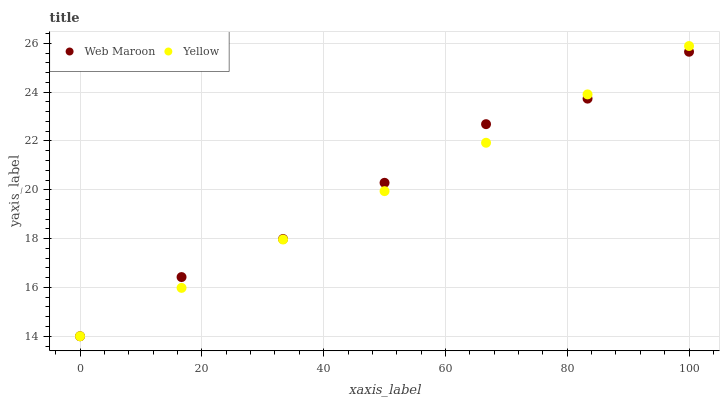Does Yellow have the minimum area under the curve?
Answer yes or no. Yes. Does Web Maroon have the maximum area under the curve?
Answer yes or no. Yes. Does Yellow have the maximum area under the curve?
Answer yes or no. No. Is Yellow the smoothest?
Answer yes or no. Yes. Is Web Maroon the roughest?
Answer yes or no. Yes. Is Yellow the roughest?
Answer yes or no. No. Does Web Maroon have the lowest value?
Answer yes or no. Yes. Does Yellow have the highest value?
Answer yes or no. Yes. Does Web Maroon intersect Yellow?
Answer yes or no. Yes. Is Web Maroon less than Yellow?
Answer yes or no. No. Is Web Maroon greater than Yellow?
Answer yes or no. No. 